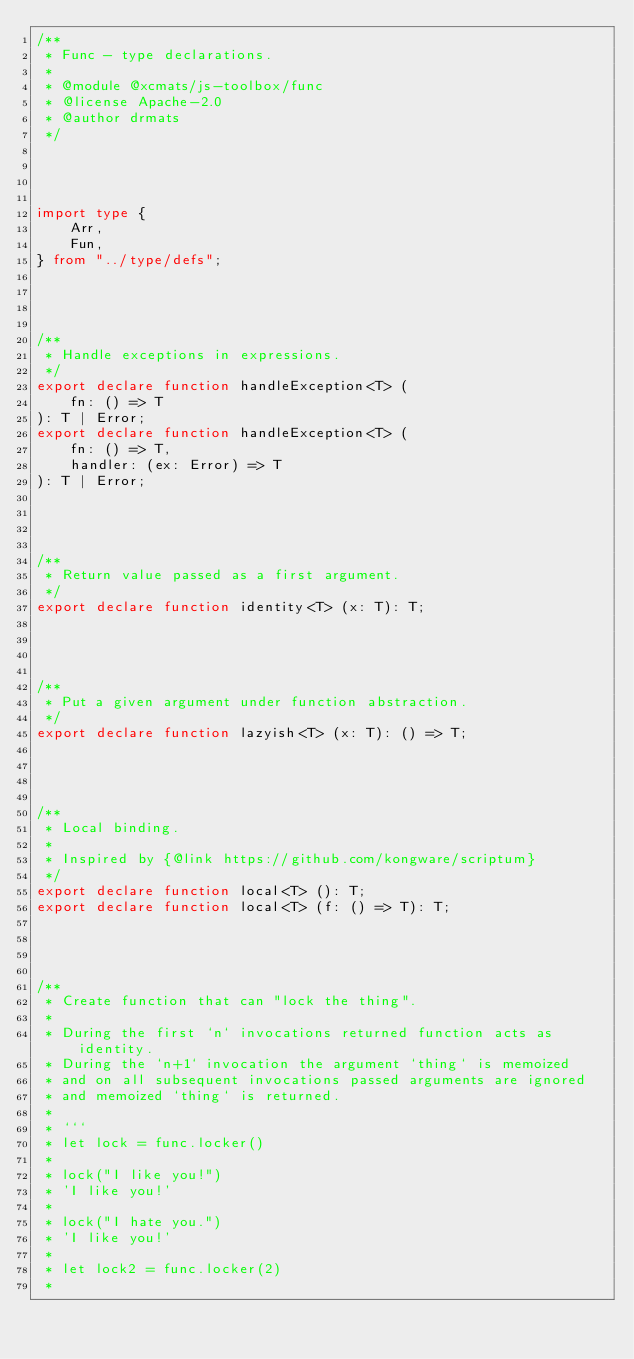<code> <loc_0><loc_0><loc_500><loc_500><_TypeScript_>/**
 * Func - type declarations.
 *
 * @module @xcmats/js-toolbox/func
 * @license Apache-2.0
 * @author drmats
 */




import type {
    Arr,
    Fun,
} from "../type/defs";




/**
 * Handle exceptions in expressions.
 */
export declare function handleException<T> (
    fn: () => T
): T | Error;
export declare function handleException<T> (
    fn: () => T,
    handler: (ex: Error) => T
): T | Error;




/**
 * Return value passed as a first argument.
 */
export declare function identity<T> (x: T): T;




/**
 * Put a given argument under function abstraction.
 */
export declare function lazyish<T> (x: T): () => T;




/**
 * Local binding.
 *
 * Inspired by {@link https://github.com/kongware/scriptum}
 */
export declare function local<T> (): T;
export declare function local<T> (f: () => T): T;




/**
 * Create function that can "lock the thing".
 *
 * During the first `n` invocations returned function acts as identity.
 * During the `n+1` invocation the argument `thing` is memoized
 * and on all subsequent invocations passed arguments are ignored
 * and memoized `thing` is returned.
 *
 * ```
 * let lock = func.locker()
 *
 * lock("I like you!")
 * 'I like you!'
 *
 * lock("I hate you.")
 * 'I like you!'
 *
 * let lock2 = func.locker(2)
 *</code> 